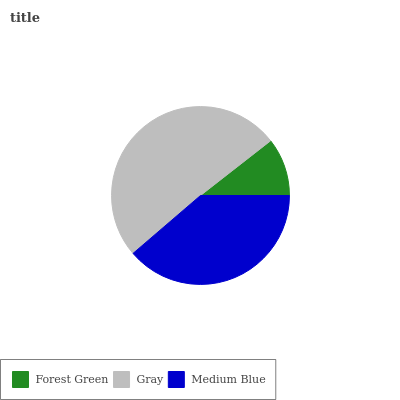Is Forest Green the minimum?
Answer yes or no. Yes. Is Gray the maximum?
Answer yes or no. Yes. Is Medium Blue the minimum?
Answer yes or no. No. Is Medium Blue the maximum?
Answer yes or no. No. Is Gray greater than Medium Blue?
Answer yes or no. Yes. Is Medium Blue less than Gray?
Answer yes or no. Yes. Is Medium Blue greater than Gray?
Answer yes or no. No. Is Gray less than Medium Blue?
Answer yes or no. No. Is Medium Blue the high median?
Answer yes or no. Yes. Is Medium Blue the low median?
Answer yes or no. Yes. Is Forest Green the high median?
Answer yes or no. No. Is Gray the low median?
Answer yes or no. No. 